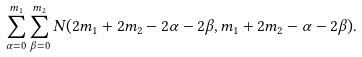Convert formula to latex. <formula><loc_0><loc_0><loc_500><loc_500>\sum _ { \alpha = 0 } ^ { m _ { 1 } } \sum _ { \beta = 0 } ^ { m _ { 2 } } N ( 2 m _ { 1 } + 2 m _ { 2 } - 2 \alpha - 2 \beta , m _ { 1 } + 2 m _ { 2 } - \alpha - 2 \beta ) .</formula> 